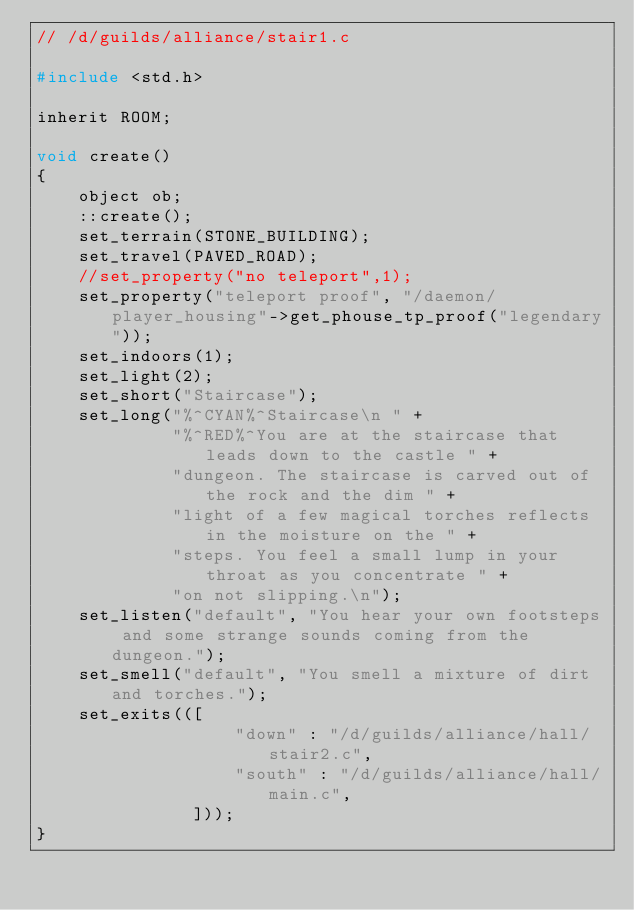<code> <loc_0><loc_0><loc_500><loc_500><_C_>// /d/guilds/alliance/stair1.c

#include <std.h>

inherit ROOM;

void create()
{
    object ob;
    ::create();
    set_terrain(STONE_BUILDING);
    set_travel(PAVED_ROAD);
    //set_property("no teleport",1);
    set_property("teleport proof", "/daemon/player_housing"->get_phouse_tp_proof("legendary"));
    set_indoors(1);
    set_light(2);
    set_short("Staircase");
    set_long("%^CYAN%^Staircase\n " +
             "%^RED%^You are at the staircase that leads down to the castle " +
             "dungeon. The staircase is carved out of the rock and the dim " +
             "light of a few magical torches reflects in the moisture on the " +
             "steps. You feel a small lump in your throat as you concentrate " +
             "on not slipping.\n");
    set_listen("default", "You hear your own footsteps and some strange sounds coming from the dungeon.");
    set_smell("default", "You smell a mixture of dirt and torches.");
    set_exits(([
                   "down" : "/d/guilds/alliance/hall/stair2.c",
                   "south" : "/d/guilds/alliance/hall/main.c",
               ]));
}
</code> 